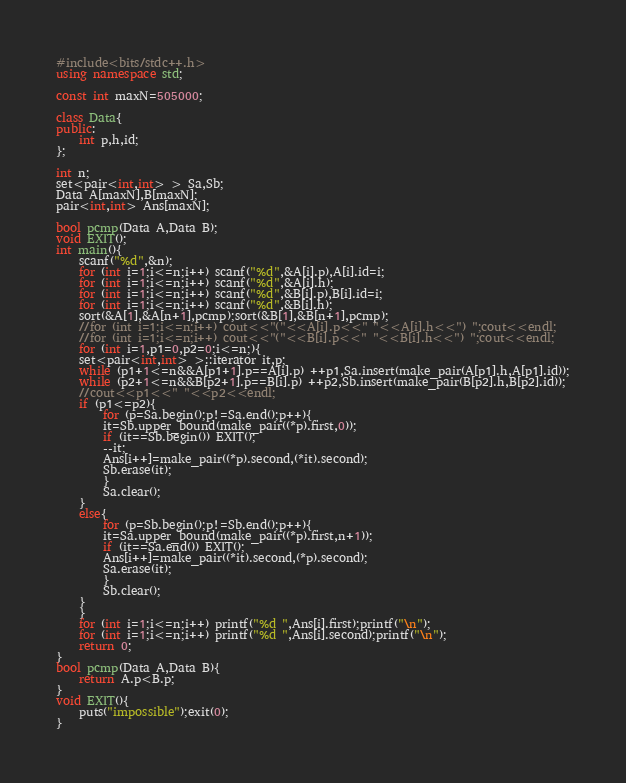<code> <loc_0><loc_0><loc_500><loc_500><_C++_>#include<bits/stdc++.h>
using namespace std;

const int maxN=505000;

class Data{
public:
    int p,h,id;
};

int n;
set<pair<int,int> > Sa,Sb;
Data A[maxN],B[maxN];
pair<int,int> Ans[maxN];

bool pcmp(Data A,Data B);
void EXIT();
int main(){
    scanf("%d",&n);
    for (int i=1;i<=n;i++) scanf("%d",&A[i].p),A[i].id=i;
    for (int i=1;i<=n;i++) scanf("%d",&A[i].h);
    for (int i=1;i<=n;i++) scanf("%d",&B[i].p),B[i].id=i;
    for (int i=1;i<=n;i++) scanf("%d",&B[i].h);
    sort(&A[1],&A[n+1],pcmp);sort(&B[1],&B[n+1],pcmp);
    //for (int i=1;i<=n;i++) cout<<"("<<A[i].p<<" "<<A[i].h<<") ";cout<<endl;
    //for (int i=1;i<=n;i++) cout<<"("<<B[i].p<<" "<<B[i].h<<") ";cout<<endl;
    for (int i=1,p1=0,p2=0;i<=n;){
	set<pair<int,int> >::iterator it,p;
	while (p1+1<=n&&A[p1+1].p==A[i].p) ++p1,Sa.insert(make_pair(A[p1].h,A[p1].id));
	while (p2+1<=n&&B[p2+1].p==B[i].p) ++p2,Sb.insert(make_pair(B[p2].h,B[p2].id));
	//cout<<p1<<" "<<p2<<endl;
	if (p1<=p2){
	    for (p=Sa.begin();p!=Sa.end();p++){
		it=Sb.upper_bound(make_pair((*p).first,0));
		if (it==Sb.begin()) EXIT();
		--it;
		Ans[i++]=make_pair((*p).second,(*it).second);
		Sb.erase(it);
	    }
	    Sa.clear();
	}
	else{
	    for (p=Sb.begin();p!=Sb.end();p++){
		it=Sa.upper_bound(make_pair((*p).first,n+1));
		if (it==Sa.end()) EXIT();
		Ans[i++]=make_pair((*it).second,(*p).second);
		Sa.erase(it);
	    }
	    Sb.clear();
	}
    }
    for (int i=1;i<=n;i++) printf("%d ",Ans[i].first);printf("\n");
    for (int i=1;i<=n;i++) printf("%d ",Ans[i].second);printf("\n");
    return 0;
}
bool pcmp(Data A,Data B){
    return A.p<B.p;
}
void EXIT(){
    puts("impossible");exit(0);
}
</code> 